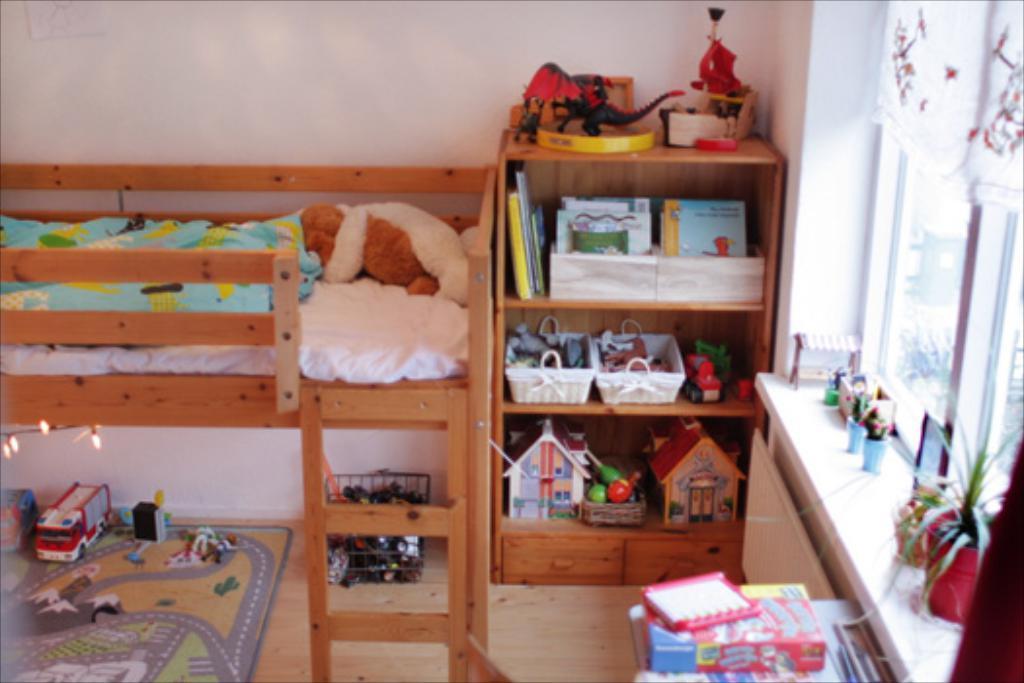Please provide a concise description of this image. In this picture we can see a carpet on the floor, toys, baskets, miniature houses, box, books, cardboard, house plants, window, curtain, ladder, bed with a bed sheet on it and some objects. In the background we can see the wall. 